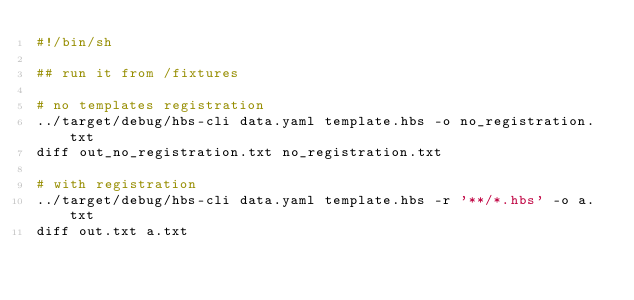<code> <loc_0><loc_0><loc_500><loc_500><_Bash_>#!/bin/sh

## run it from /fixtures

# no templates registration
../target/debug/hbs-cli data.yaml template.hbs -o no_registration.txt
diff out_no_registration.txt no_registration.txt

# with registration
../target/debug/hbs-cli data.yaml template.hbs -r '**/*.hbs' -o a.txt
diff out.txt a.txt
</code> 